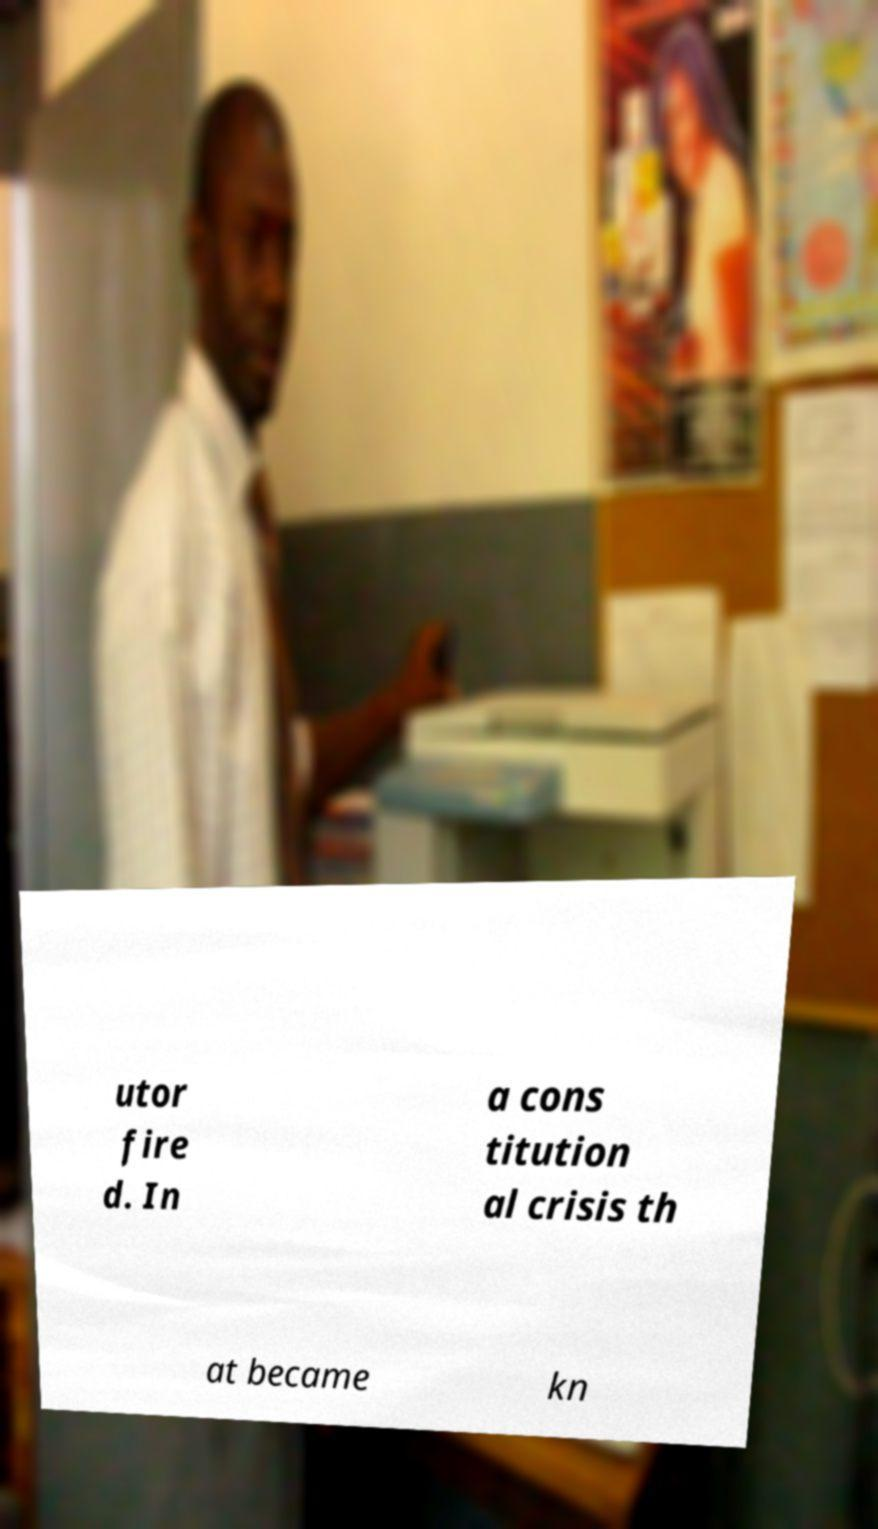Can you accurately transcribe the text from the provided image for me? utor fire d. In a cons titution al crisis th at became kn 